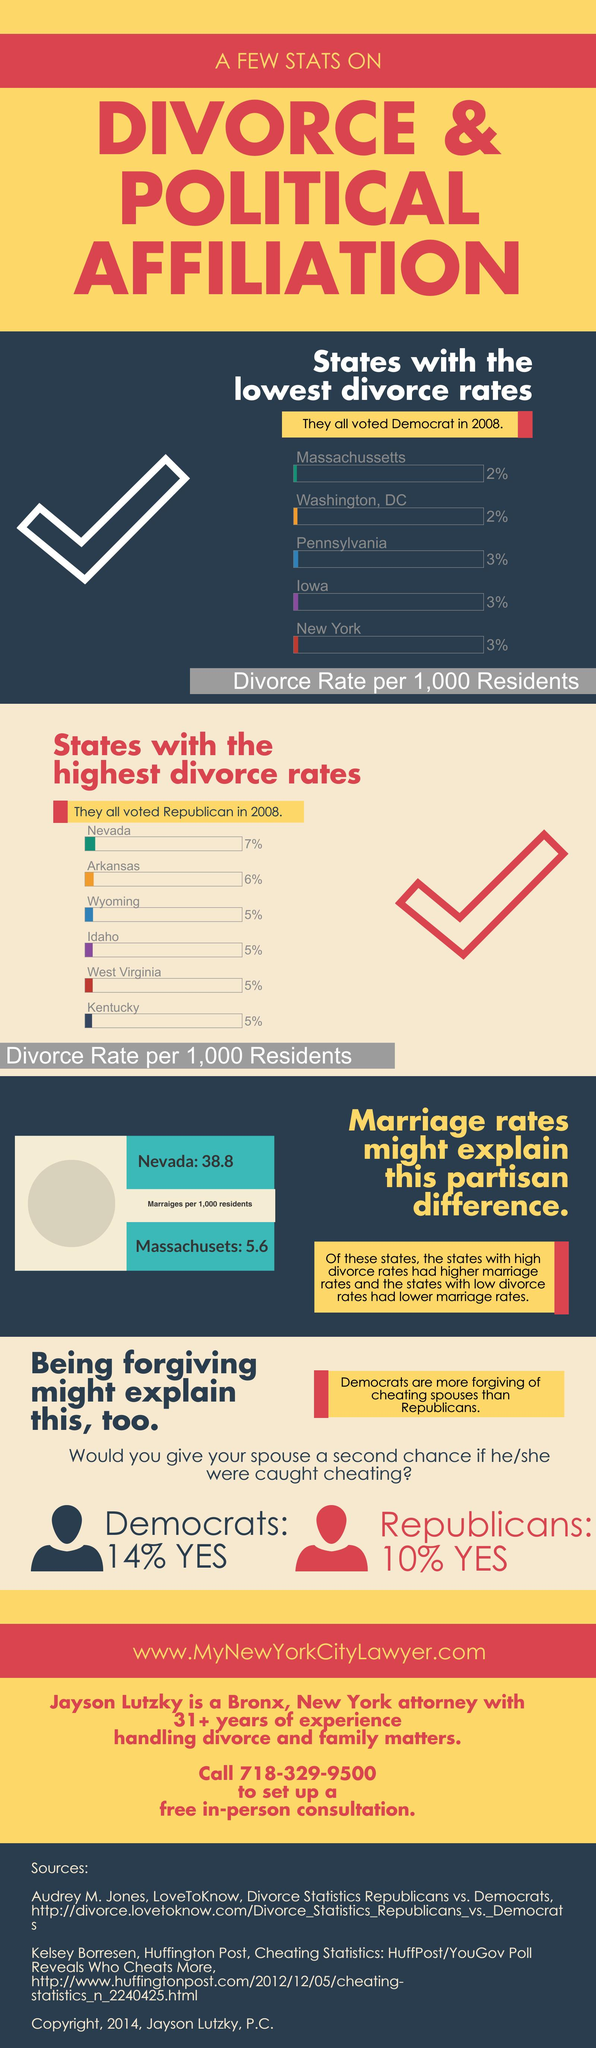Indicate a few pertinent items in this graphic. The state with the second-highest divorce rate is Arkansas. According to a recent survey, only 10% of Republicans would give their husband another chance if they were found to be dishonest. There are states in which the divorce rate is equal to 2%. A small number of states have a divorce rate that is equal to 3%. 